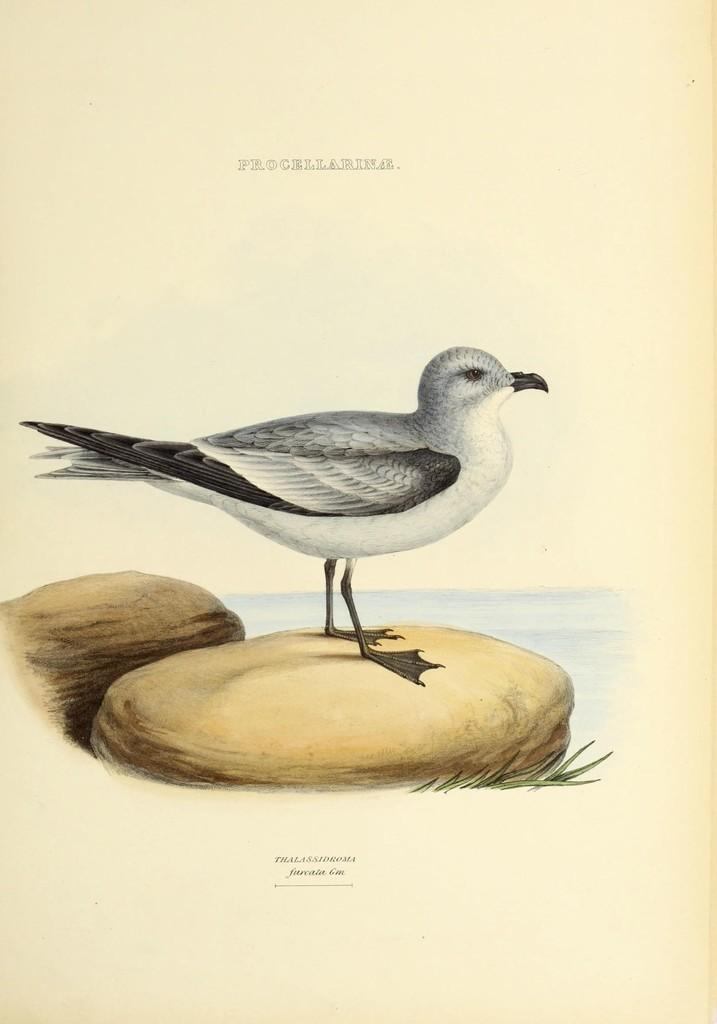What is the main subject of the image? The main subject of the image is a bird. Where is the bird located in the image? The bird is on a rock in the image. What else can be seen in the image besides the bird? There are letters on a paper in the image. What type of button is the bird using to fly in the image? There is no button present in the image, and the bird is not using any device to fly. 